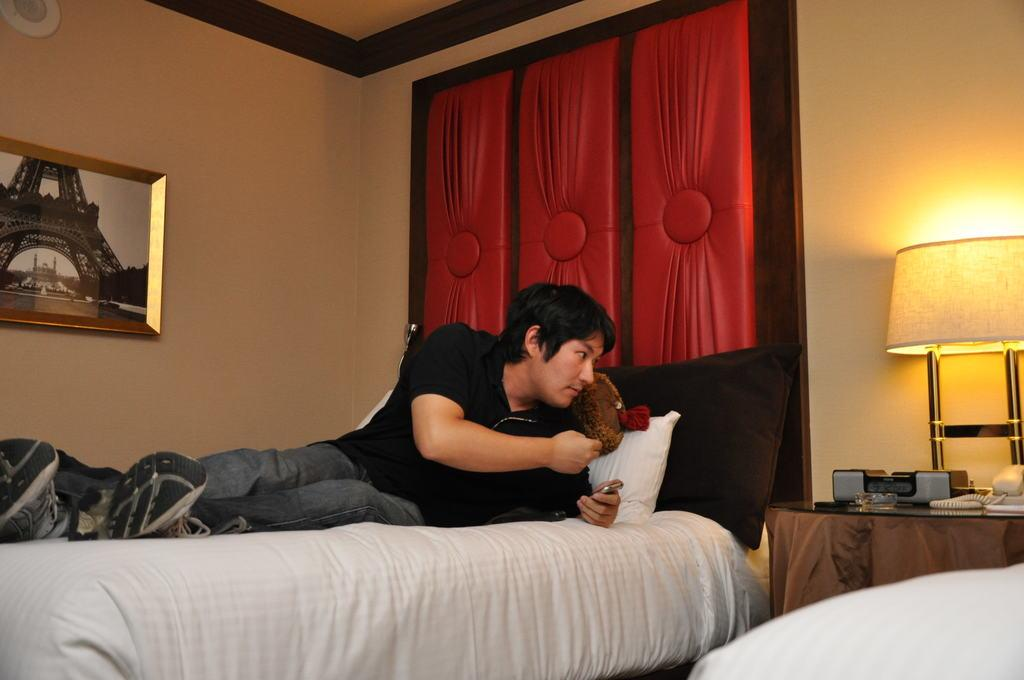What type of structure can be seen in the image? There is a wall in the image. What is hanging on the wall? There is a photo frame in the image. What type of lighting is present in the image? There is a lamp in the image. What type of furniture is present in the image? There is a bed in the image. What is the man doing in the image? The man is laying on the bed in the image. Where is the basin located in the image? There is no basin present in the image. 